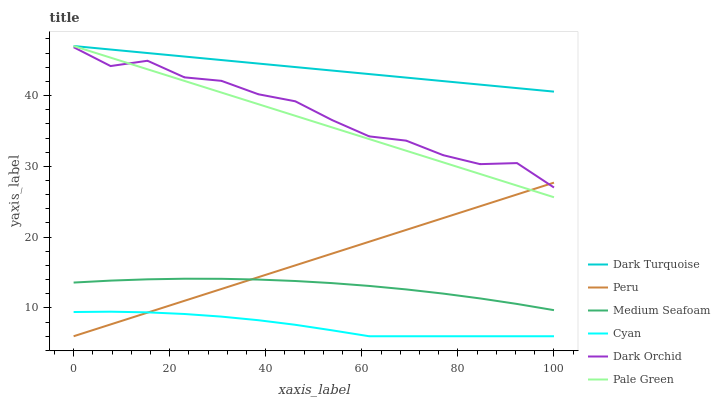Does Cyan have the minimum area under the curve?
Answer yes or no. Yes. Does Dark Turquoise have the maximum area under the curve?
Answer yes or no. Yes. Does Dark Orchid have the minimum area under the curve?
Answer yes or no. No. Does Dark Orchid have the maximum area under the curve?
Answer yes or no. No. Is Peru the smoothest?
Answer yes or no. Yes. Is Dark Orchid the roughest?
Answer yes or no. Yes. Is Pale Green the smoothest?
Answer yes or no. No. Is Pale Green the roughest?
Answer yes or no. No. Does Peru have the lowest value?
Answer yes or no. Yes. Does Dark Orchid have the lowest value?
Answer yes or no. No. Does Pale Green have the highest value?
Answer yes or no. Yes. Does Dark Orchid have the highest value?
Answer yes or no. No. Is Peru less than Dark Turquoise?
Answer yes or no. Yes. Is Dark Turquoise greater than Dark Orchid?
Answer yes or no. Yes. Does Dark Orchid intersect Peru?
Answer yes or no. Yes. Is Dark Orchid less than Peru?
Answer yes or no. No. Is Dark Orchid greater than Peru?
Answer yes or no. No. Does Peru intersect Dark Turquoise?
Answer yes or no. No. 